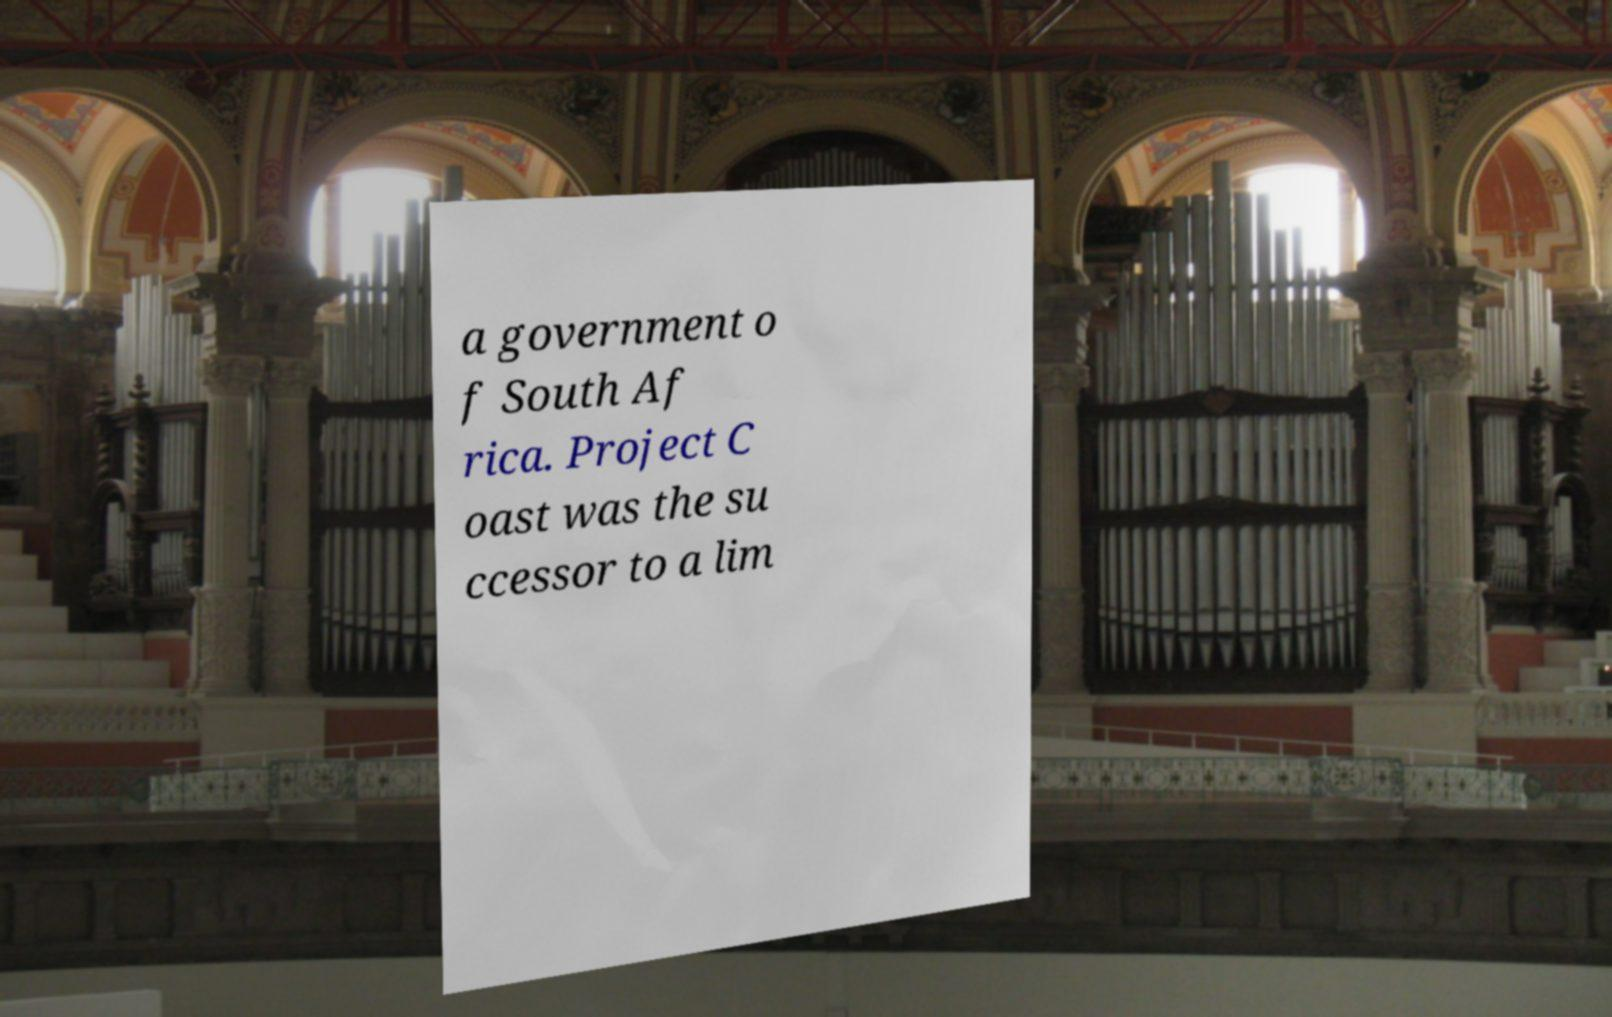I need the written content from this picture converted into text. Can you do that? a government o f South Af rica. Project C oast was the su ccessor to a lim 